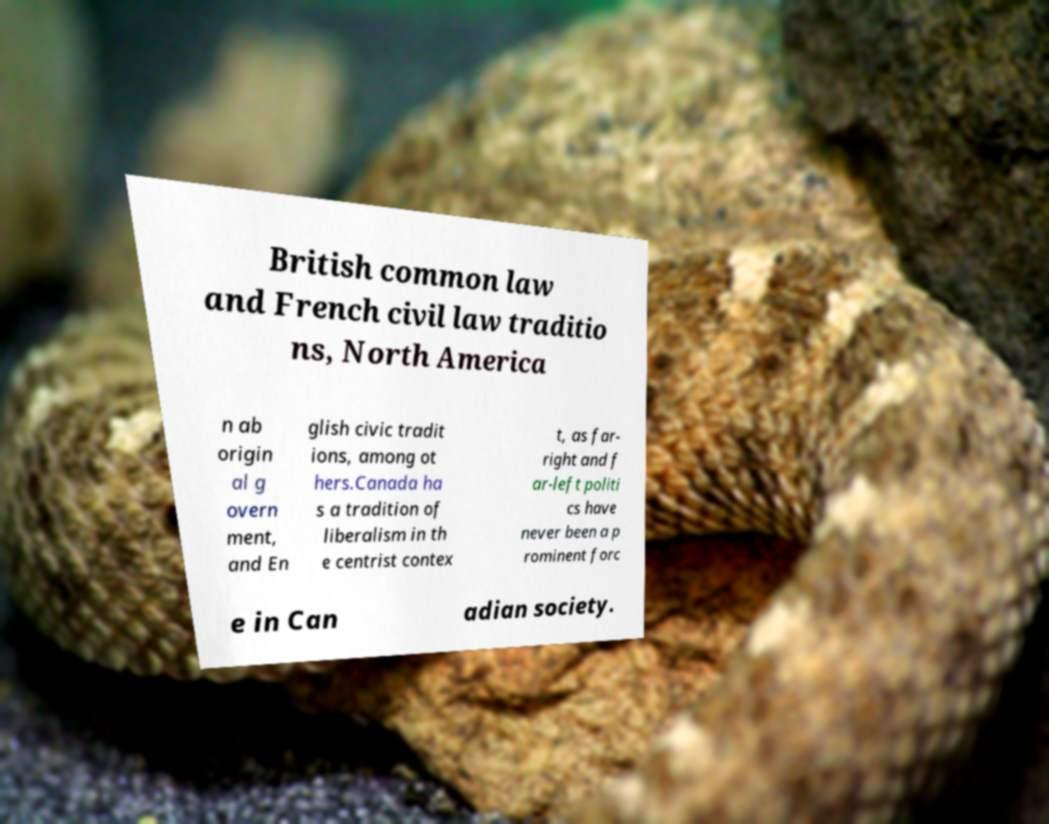There's text embedded in this image that I need extracted. Can you transcribe it verbatim? British common law and French civil law traditio ns, North America n ab origin al g overn ment, and En glish civic tradit ions, among ot hers.Canada ha s a tradition of liberalism in th e centrist contex t, as far- right and f ar-left politi cs have never been a p rominent forc e in Can adian society. 